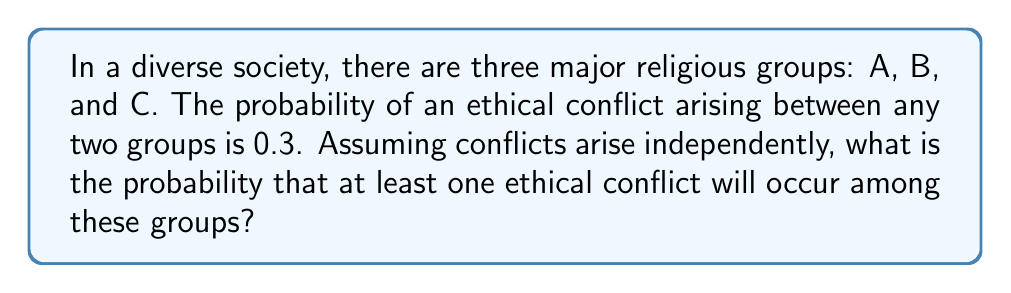Help me with this question. Let's approach this step-by-step:

1) First, we need to identify the total number of possible conflicts. With three groups, we have three possible conflict pairs: A-B, B-C, and A-C.

2) The probability of a conflict occurring between any two groups is 0.3. Therefore, the probability of no conflict between any two groups is 1 - 0.3 = 0.7.

3) For at least one conflict to occur, we can calculate the probability of its complement event: the probability that no conflicts occur at all.

4) The probability of no conflicts occurring is the product of the probabilities of no conflict for each pair, as the events are independent:

   $P(\text{no conflicts}) = 0.7 \times 0.7 \times 0.7 = 0.7^3 = 0.343$

5) Therefore, the probability of at least one conflict occurring is:

   $P(\text{at least one conflict}) = 1 - P(\text{no conflicts})$
   
   $= 1 - 0.343 = 0.657$

6) We can also express this using the probability formula:

   $P(\text{at least one conflict}) = 1 - (1-p)^n$

   Where $p$ is the probability of a conflict between any two groups (0.3), and $n$ is the number of possible conflict pairs (3).

   $= 1 - (1-0.3)^3 = 1 - 0.7^3 = 0.657$
Answer: 0.657 